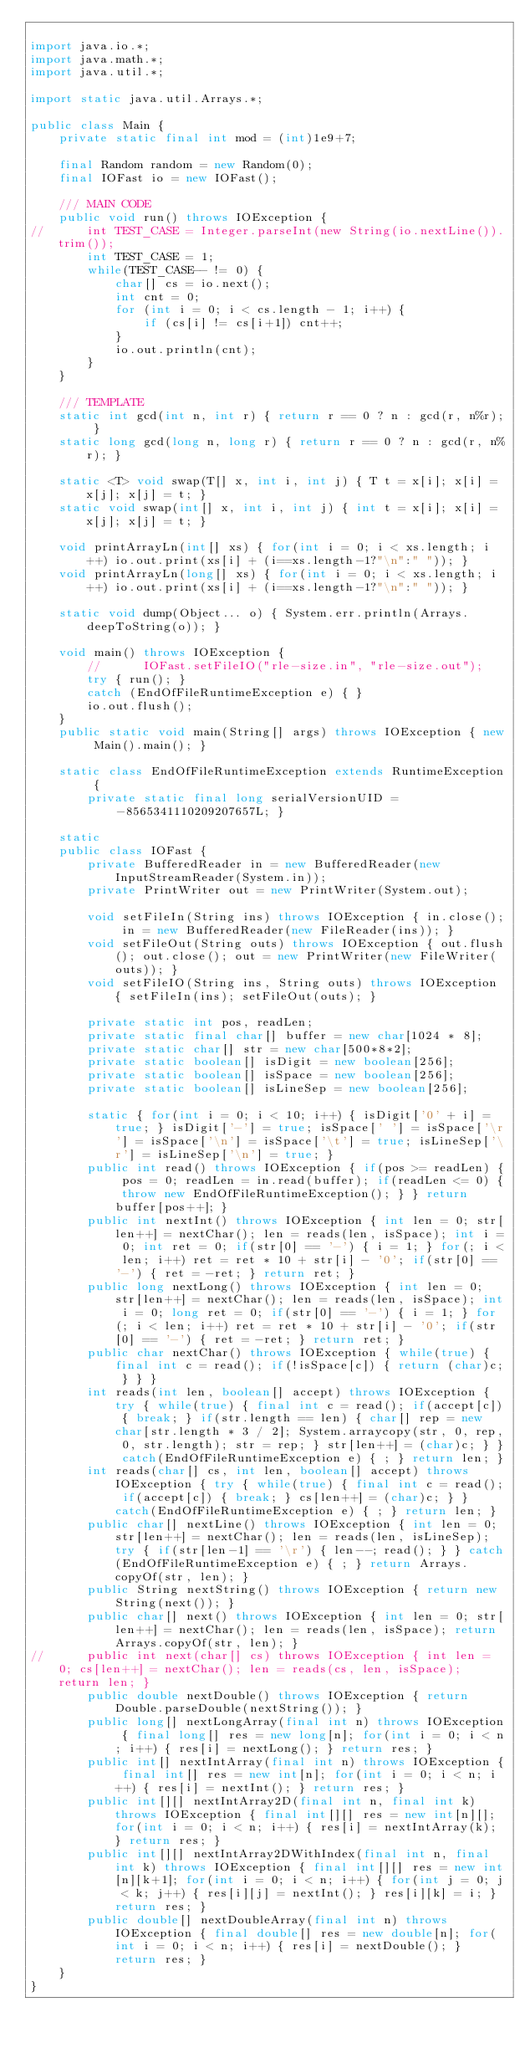Convert code to text. <code><loc_0><loc_0><loc_500><loc_500><_Java_>
import java.io.*;
import java.math.*;
import java.util.*;

import static java.util.Arrays.*;

public class Main {
	private static final int mod = (int)1e9+7;

	final Random random = new Random(0);
	final IOFast io = new IOFast();

	/// MAIN CODE
	public void run() throws IOException {
//		int TEST_CASE = Integer.parseInt(new String(io.nextLine()).trim());
		int TEST_CASE = 1;
		while(TEST_CASE-- != 0) {
			char[] cs = io.next();
			int cnt = 0;
			for (int i = 0; i < cs.length - 1; i++) {
				if (cs[i] != cs[i+1]) cnt++;
			}
			io.out.println(cnt);
		}
	}

	/// TEMPLATE
	static int gcd(int n, int r) { return r == 0 ? n : gcd(r, n%r); }
	static long gcd(long n, long r) { return r == 0 ? n : gcd(r, n%r); }
	
	static <T> void swap(T[] x, int i, int j) { T t = x[i]; x[i] = x[j]; x[j] = t; }
	static void swap(int[] x, int i, int j) { int t = x[i]; x[i] = x[j]; x[j] = t; }

	void printArrayLn(int[] xs) { for(int i = 0; i < xs.length; i++) io.out.print(xs[i] + (i==xs.length-1?"\n":" ")); }
	void printArrayLn(long[] xs) { for(int i = 0; i < xs.length; i++) io.out.print(xs[i] + (i==xs.length-1?"\n":" ")); }
	
	static void dump(Object... o) { System.err.println(Arrays.deepToString(o)); } 
	
	void main() throws IOException {
		//		IOFast.setFileIO("rle-size.in", "rle-size.out");
		try { run(); }
		catch (EndOfFileRuntimeException e) { }
		io.out.flush();
	}
	public static void main(String[] args) throws IOException { new Main().main(); }
	
	static class EndOfFileRuntimeException extends RuntimeException {
		private static final long serialVersionUID = -8565341110209207657L; }

	static
	public class IOFast {
		private BufferedReader in = new BufferedReader(new InputStreamReader(System.in));
		private PrintWriter out = new PrintWriter(System.out);

		void setFileIn(String ins) throws IOException { in.close(); in = new BufferedReader(new FileReader(ins)); }
		void setFileOut(String outs) throws IOException { out.flush(); out.close(); out = new PrintWriter(new FileWriter(outs)); }
		void setFileIO(String ins, String outs) throws IOException { setFileIn(ins); setFileOut(outs); }

		private static int pos, readLen;
		private static final char[] buffer = new char[1024 * 8];
		private static char[] str = new char[500*8*2];
		private static boolean[] isDigit = new boolean[256];
		private static boolean[] isSpace = new boolean[256];
		private static boolean[] isLineSep = new boolean[256];

		static { for(int i = 0; i < 10; i++) { isDigit['0' + i] = true; } isDigit['-'] = true; isSpace[' '] = isSpace['\r'] = isSpace['\n'] = isSpace['\t'] = true; isLineSep['\r'] = isLineSep['\n'] = true; }
		public int read() throws IOException { if(pos >= readLen) { pos = 0; readLen = in.read(buffer); if(readLen <= 0) { throw new EndOfFileRuntimeException(); } } return buffer[pos++]; }
		public int nextInt() throws IOException { int len = 0; str[len++] = nextChar(); len = reads(len, isSpace); int i = 0; int ret = 0; if(str[0] == '-') { i = 1; } for(; i < len; i++) ret = ret * 10 + str[i] - '0'; if(str[0] == '-') { ret = -ret; } return ret; }
		public long nextLong() throws IOException { int len = 0; str[len++] = nextChar(); len = reads(len, isSpace); int i = 0; long ret = 0; if(str[0] == '-') { i = 1; } for(; i < len; i++) ret = ret * 10 + str[i] - '0'; if(str[0] == '-') { ret = -ret; } return ret; }
		public char nextChar() throws IOException { while(true) { final int c = read(); if(!isSpace[c]) { return (char)c; } } }
		int reads(int len, boolean[] accept) throws IOException { try { while(true) { final int c = read(); if(accept[c]) { break; } if(str.length == len) { char[] rep = new char[str.length * 3 / 2]; System.arraycopy(str, 0, rep, 0, str.length); str = rep; } str[len++] = (char)c; } } catch(EndOfFileRuntimeException e) { ; } return len; }
		int reads(char[] cs, int len, boolean[] accept) throws IOException { try { while(true) { final int c = read(); if(accept[c]) { break; } cs[len++] = (char)c; } } catch(EndOfFileRuntimeException e) { ; } return len; }
		public char[] nextLine() throws IOException { int len = 0; str[len++] = nextChar(); len = reads(len, isLineSep); try { if(str[len-1] == '\r') { len--; read(); } } catch(EndOfFileRuntimeException e) { ; } return Arrays.copyOf(str, len); }
		public String nextString() throws IOException { return new String(next()); }
		public char[] next() throws IOException { int len = 0; str[len++] = nextChar(); len = reads(len, isSpace); return Arrays.copyOf(str, len); }
//		public int next(char[] cs) throws IOException { int len = 0; cs[len++] = nextChar(); len = reads(cs, len, isSpace); return len; }
		public double nextDouble() throws IOException { return Double.parseDouble(nextString()); }
		public long[] nextLongArray(final int n) throws IOException { final long[] res = new long[n]; for(int i = 0; i < n; i++) { res[i] = nextLong(); } return res; }
		public int[] nextIntArray(final int n) throws IOException { final int[] res = new int[n]; for(int i = 0; i < n; i++) { res[i] = nextInt(); } return res; }
		public int[][] nextIntArray2D(final int n, final int k) throws IOException { final int[][] res = new int[n][]; for(int i = 0; i < n; i++) { res[i] = nextIntArray(k); } return res; }
		public int[][] nextIntArray2DWithIndex(final int n, final int k) throws IOException { final int[][] res = new int[n][k+1]; for(int i = 0; i < n; i++) { for(int j = 0; j < k; j++) { res[i][j] = nextInt(); } res[i][k] = i; } return res; }
		public double[] nextDoubleArray(final int n) throws IOException { final double[] res = new double[n]; for(int i = 0; i < n; i++) { res[i] = nextDouble(); } return res; }
	}
}
</code> 